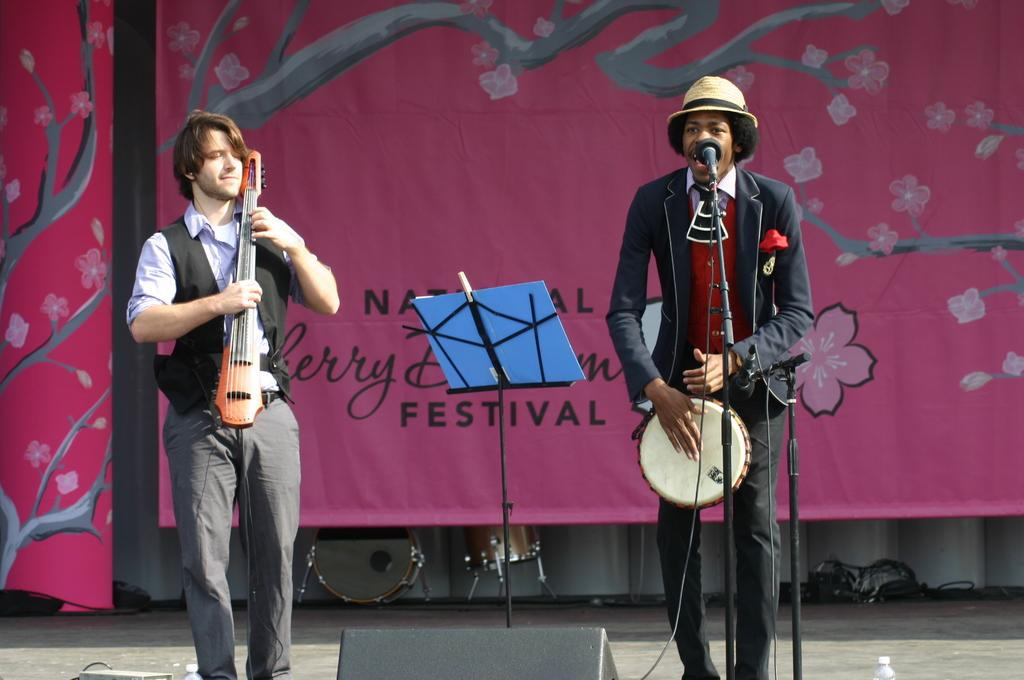How many people are in the image? There are two persons in the image. What are the persons doing in the image? The persons are playing musical instruments. Is there any additional information visible in the image? Yes, there is a banner visible in the image. What is one person doing while playing an instrument? One person is singing in front of a microphone. What type of arch can be seen in the image? There is no arch present in the image. How do the waves affect the musical performance in the image? There are no waves present in the image, so they cannot affect the musical performance. 